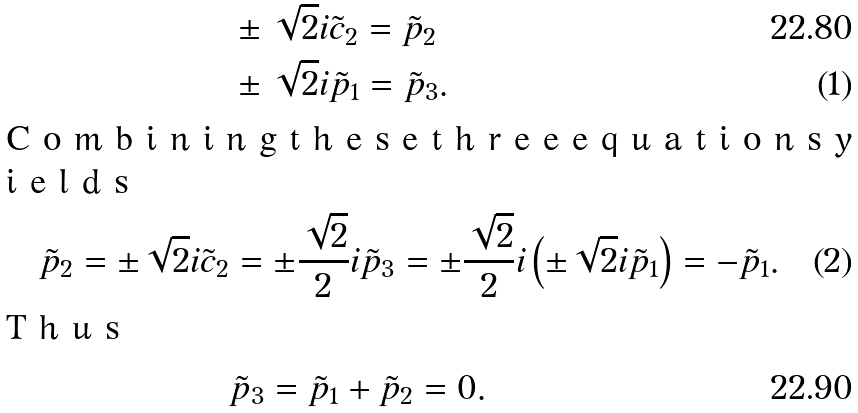Convert formula to latex. <formula><loc_0><loc_0><loc_500><loc_500>& \pm \sqrt { 2 } i \tilde { c } _ { 2 } = \tilde { p } _ { 2 } \\ & \pm \sqrt { 2 } i \tilde { p } _ { 1 } = \tilde { p } _ { 3 } . \intertext { C o m b i n i n g t h e s e t h r e e e q u a t i o n s y i e l d s } \tilde { p } _ { 2 } = \pm \sqrt { 2 } i \tilde { c } _ { 2 } & = \pm \frac { \sqrt { 2 } } { 2 } i \tilde { p } _ { 3 } = \pm \frac { \sqrt { 2 } } { 2 } i \left ( \pm \sqrt { 2 } i \tilde { p } _ { 1 } \right ) = - \tilde { p } _ { 1 } . \intertext { T h u s } & \tilde { p } _ { 3 } = \tilde { p } _ { 1 } + \tilde { p } _ { 2 } = 0 .</formula> 